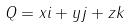<formula> <loc_0><loc_0><loc_500><loc_500>Q = x i + y j + z k</formula> 